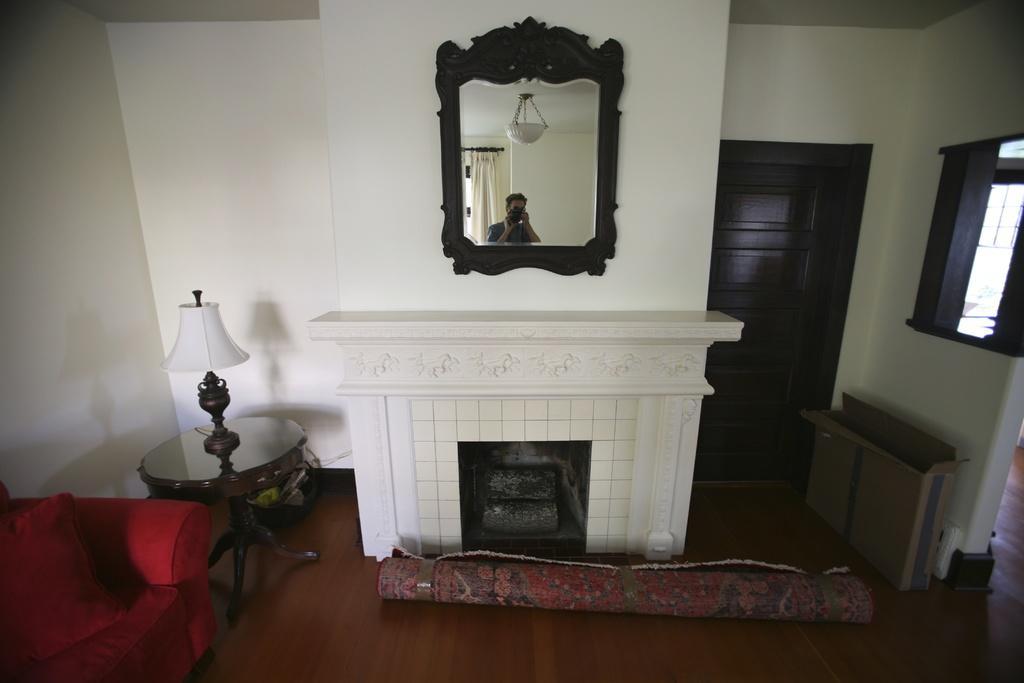In one or two sentences, can you explain what this image depicts? There is a mirror in which a person holding camera back to him there is a curtain. Beside to the mirror there is a table having lump on top of it. To the left bottom there is a red colour sofa having cushion. On floor there is folded carpet aside to that there is a cardboard box. There is a wooden door beside to it. 